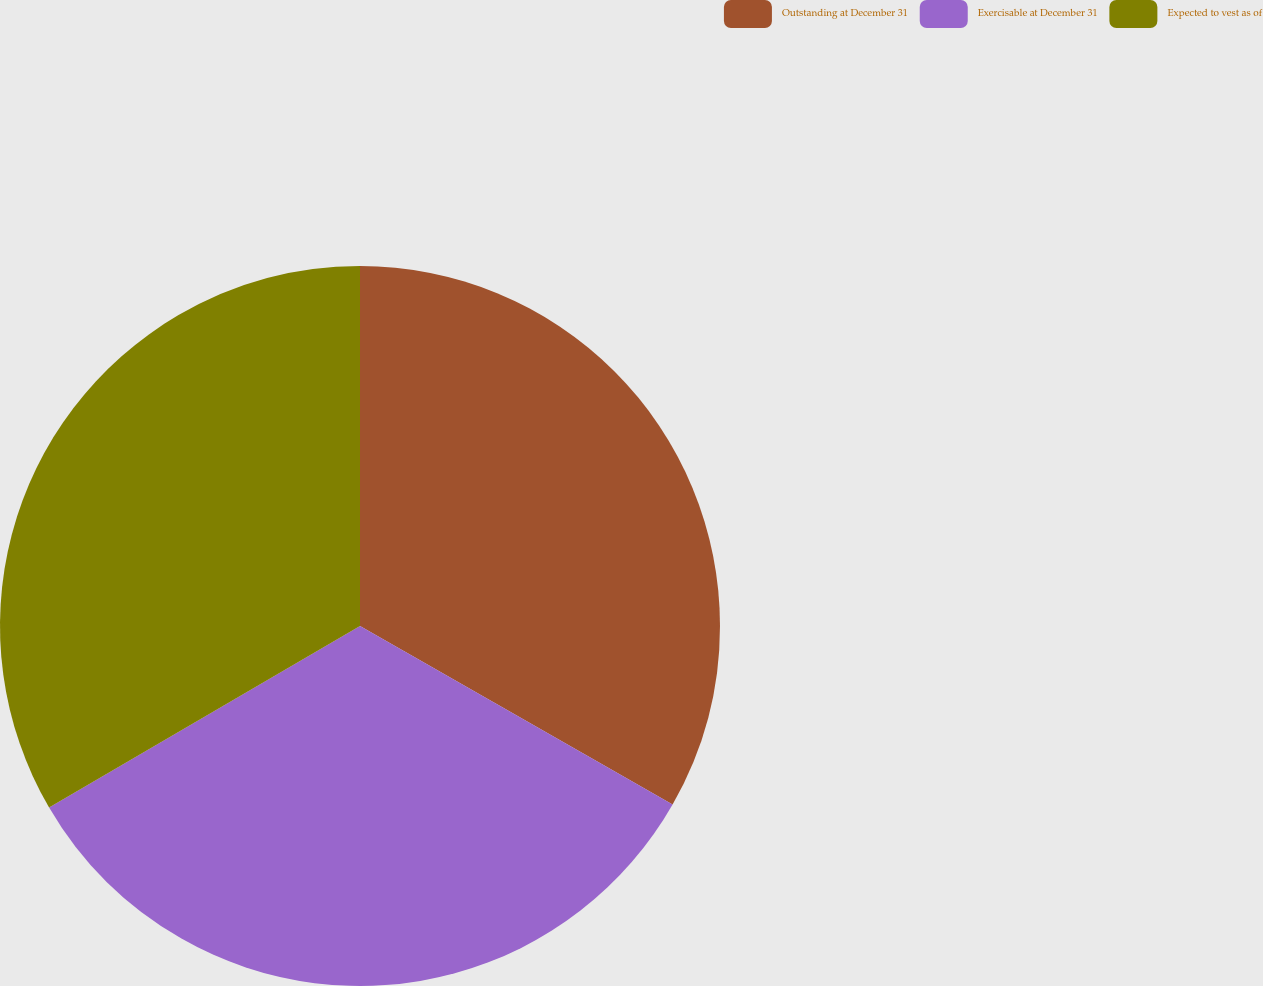Convert chart to OTSL. <chart><loc_0><loc_0><loc_500><loc_500><pie_chart><fcel>Outstanding at December 31<fcel>Exercisable at December 31<fcel>Expected to vest as of<nl><fcel>33.26%<fcel>33.33%<fcel>33.41%<nl></chart> 